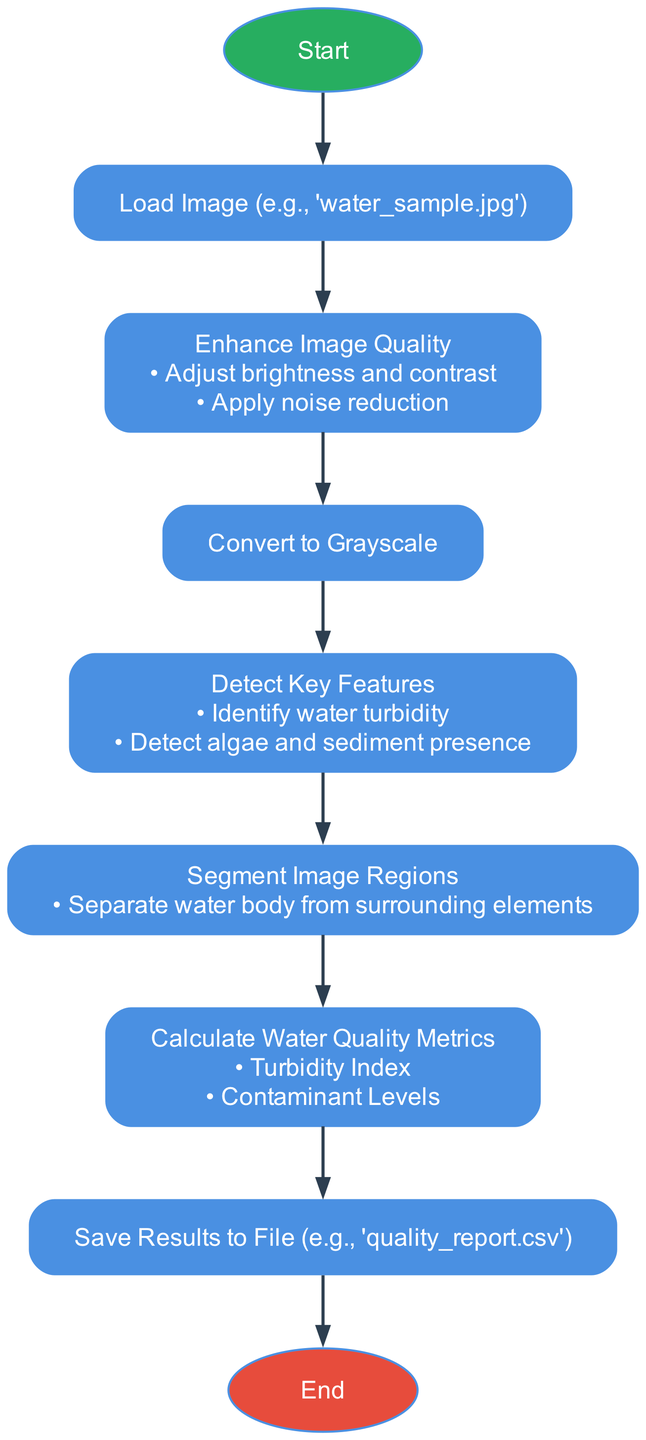What is the first step in the diagram? The first step in the flowchart is the "Start" point, indicating the initiation of the process.
Answer: Start How many main processing steps are in the diagram? The main processing steps in the flowchart are: Load Image, Enhance Image Quality, Convert to Grayscale, Detect Key Features, Segment Image Regions, Calculate Water Quality Metrics, and Save Results to File. Counting these gives us seven steps.
Answer: 7 What metrics are calculated for water quality? The flowchart mentions the calculation of two water quality metrics: Turbidity Index and Contaminant Levels.
Answer: Turbidity Index, Contaminant Levels What operation follows image enhancement? After the "Enhance Image Quality" step, the next operation in the flowchart is "Convert to Grayscale."
Answer: Convert to Grayscale Which step addresses the identification of water quality issues? "Detect Key Features" is the step that focuses on identifying various water quality issues such as turbidity and algae presence.
Answer: Detect Key Features In what file format are the results saved? The results are saved to a file in CSV format, as indicated in the step "Save Results to File."
Answer: quality_report.csv How many stages require processing after loading the image? After the "Load Image" step, there are six processing steps that follow: Enhance Image Quality, Convert to Grayscale, Detect Key Features, Segment Image Regions, Calculate Water Quality Metrics, and Save Results to File.
Answer: 6 What step comes directly before saving the results? The step that comes directly before "Save Results to File" is "Calculate Water Quality Metrics."
Answer: Calculate Water Quality Metrics What is the end point of the diagram? The end point of the flowchart is labeled as "End," which signifies the completion of the image preprocessing process.
Answer: End 